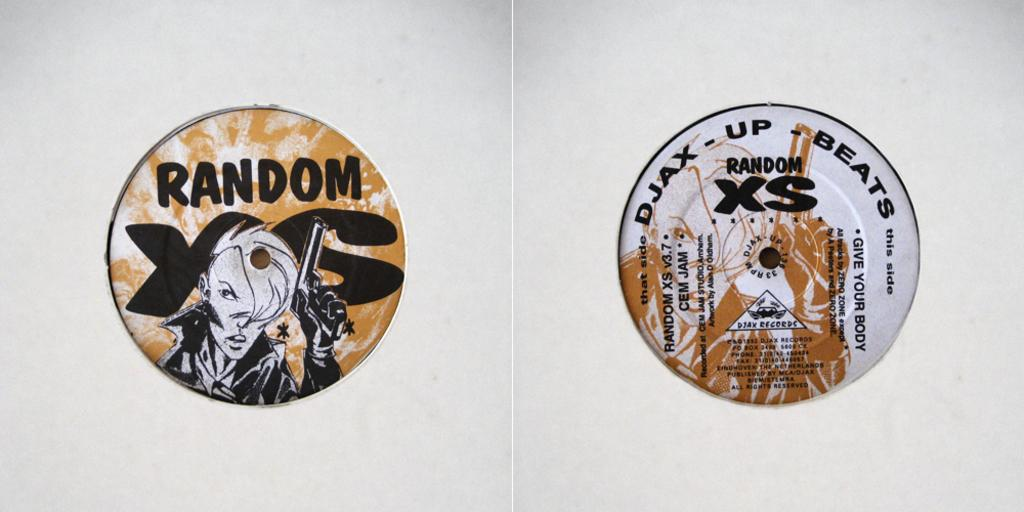<image>
Provide a brief description of the given image. Two Cds in white cases one of which says Random. 